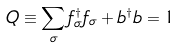Convert formula to latex. <formula><loc_0><loc_0><loc_500><loc_500>Q \equiv \sum _ { \sigma } f ^ { \dagger } _ { \sigma } f _ { \sigma } + b ^ { \dagger } b = 1</formula> 